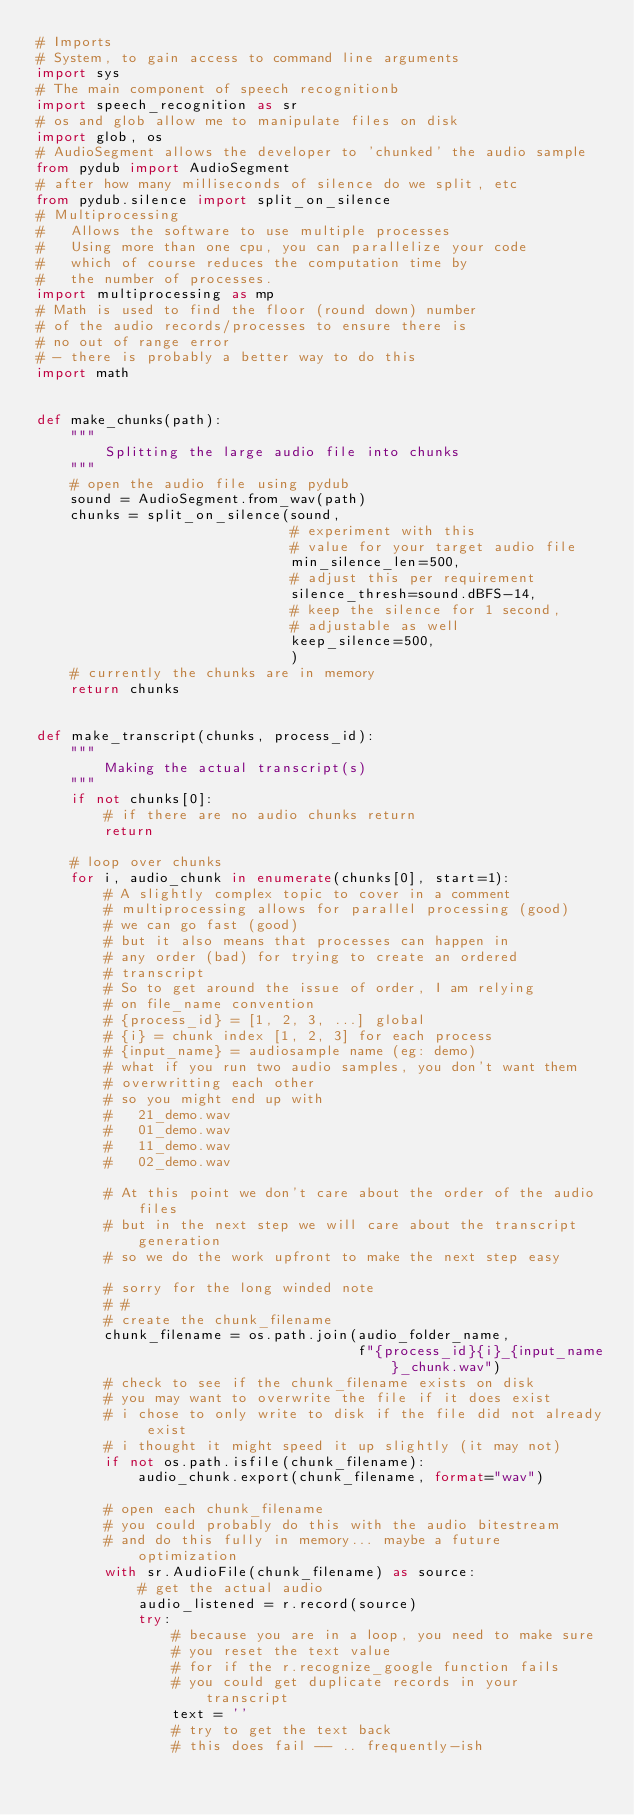Convert code to text. <code><loc_0><loc_0><loc_500><loc_500><_Python_># Imports
# System, to gain access to command line arguments
import sys
# The main component of speech recognitionb
import speech_recognition as sr
# os and glob allow me to manipulate files on disk
import glob, os
# AudioSegment allows the developer to 'chunked' the audio sample
from pydub import AudioSegment
# after how many milliseconds of silence do we split, etc
from pydub.silence import split_on_silence
# Multiprocessing
#   Allows the software to use multiple processes
#   Using more than one cpu, you can parallelize your code
#   which of course reduces the computation time by
#   the number of processes.
import multiprocessing as mp
# Math is used to find the floor (round down) number
# of the audio records/processes to ensure there is
# no out of range error
# - there is probably a better way to do this
import math


def make_chunks(path):
    """
        Splitting the large audio file into chunks
    """
    # open the audio file using pydub
    sound = AudioSegment.from_wav(path)
    chunks = split_on_silence(sound,
                              # experiment with this
                              # value for your target audio file
                              min_silence_len=500,
                              # adjust this per requirement
                              silence_thresh=sound.dBFS-14,
                              # keep the silence for 1 second,
                              # adjustable as well
                              keep_silence=500,
                              )
    # currently the chunks are in memory
    return chunks


def make_transcript(chunks, process_id):
    """
        Making the actual transcript(s)
    """
    if not chunks[0]:
        # if there are no audio chunks return
        return

    # loop over chunks
    for i, audio_chunk in enumerate(chunks[0], start=1):
        # A slightly complex topic to cover in a comment
        # multiprocessing allows for parallel processing (good)
        # we can go fast (good)
        # but it also means that processes can happen in
        # any order (bad) for trying to create an ordered
        # transcript
        # So to get around the issue of order, I am relying
        # on file_name convention
        # {process_id} = [1, 2, 3, ...] global
        # {i} = chunk index [1, 2, 3] for each process
        # {input_name} = audiosample name (eg: demo)
        # what if you run two audio samples, you don't want them
        # overwritting each other
        # so you might end up with
        #   21_demo.wav
        #   01_demo.wav
        #   11_demo.wav
        #   02_demo.wav

        # At this point we don't care about the order of the audio files
        # but in the next step we will care about the transcript generation
        # so we do the work upfront to make the next step easy

        # sorry for the long winded note
        # #
        # create the chunk_filename
        chunk_filename = os.path.join(audio_folder_name,
                                      f"{process_id}{i}_{input_name}_chunk.wav")
        # check to see if the chunk_filename exists on disk
        # you may want to overwrite the file if it does exist
        # i chose to only write to disk if the file did not already exist
        # i thought it might speed it up slightly (it may not)
        if not os.path.isfile(chunk_filename):
            audio_chunk.export(chunk_filename, format="wav")

        # open each chunk_filename
        # you could probably do this with the audio bitestream
        # and do this fully in memory... maybe a future optimization
        with sr.AudioFile(chunk_filename) as source:
            # get the actual audio
            audio_listened = r.record(source)
            try:
                # because you are in a loop, you need to make sure
                # you reset the text value
                # for if the r.recognize_google function fails
                # you could get duplicate records in your transcript
                text = ''
                # try to get the text back
                # this does fail -- .. frequently-ish</code> 